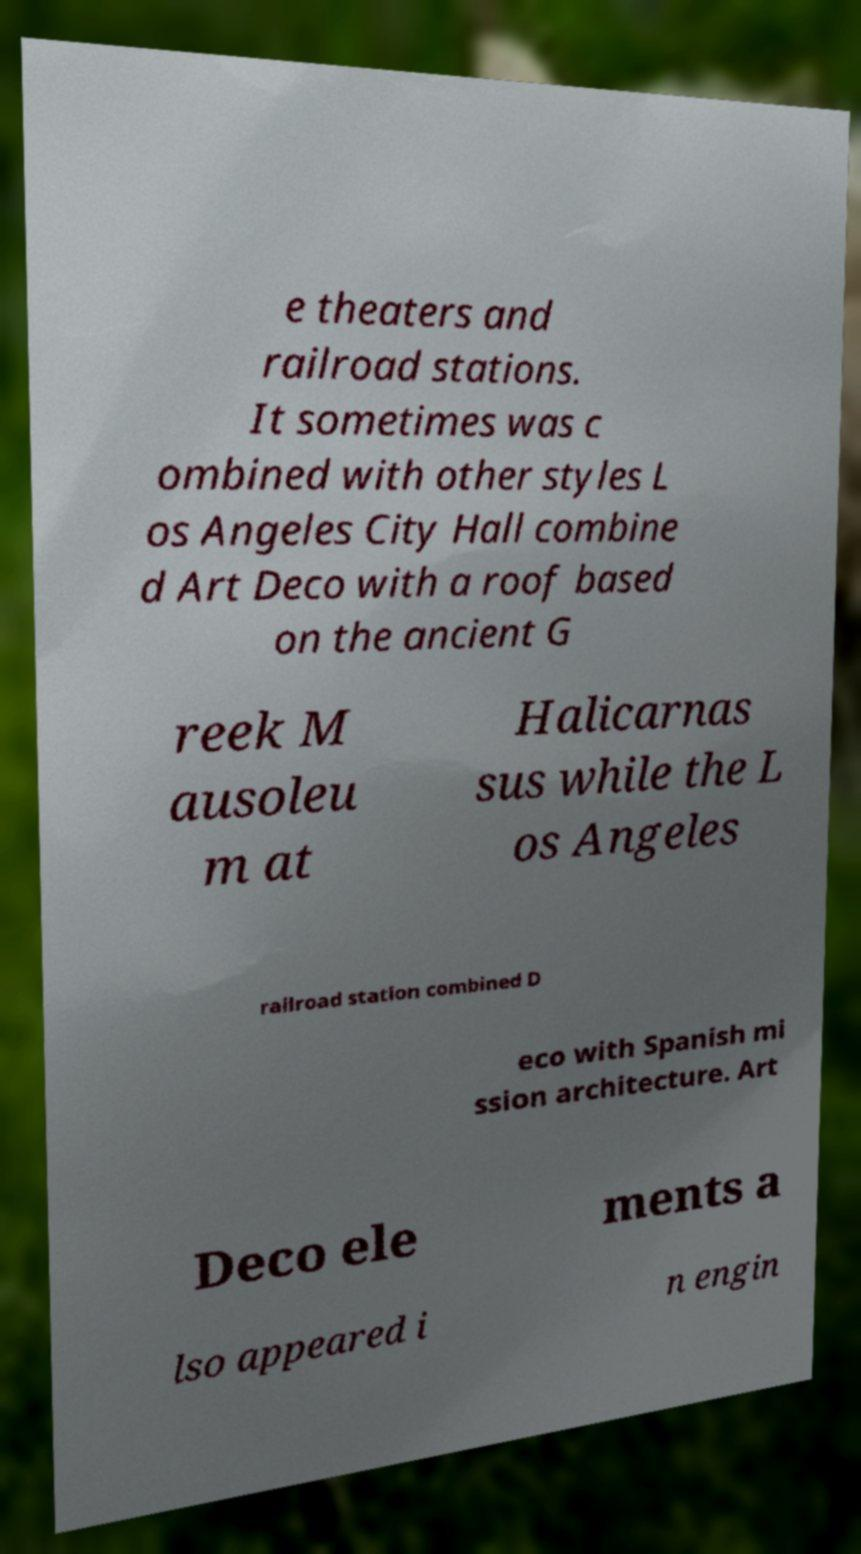Please read and relay the text visible in this image. What does it say? e theaters and railroad stations. It sometimes was c ombined with other styles L os Angeles City Hall combine d Art Deco with a roof based on the ancient G reek M ausoleu m at Halicarnas sus while the L os Angeles railroad station combined D eco with Spanish mi ssion architecture. Art Deco ele ments a lso appeared i n engin 